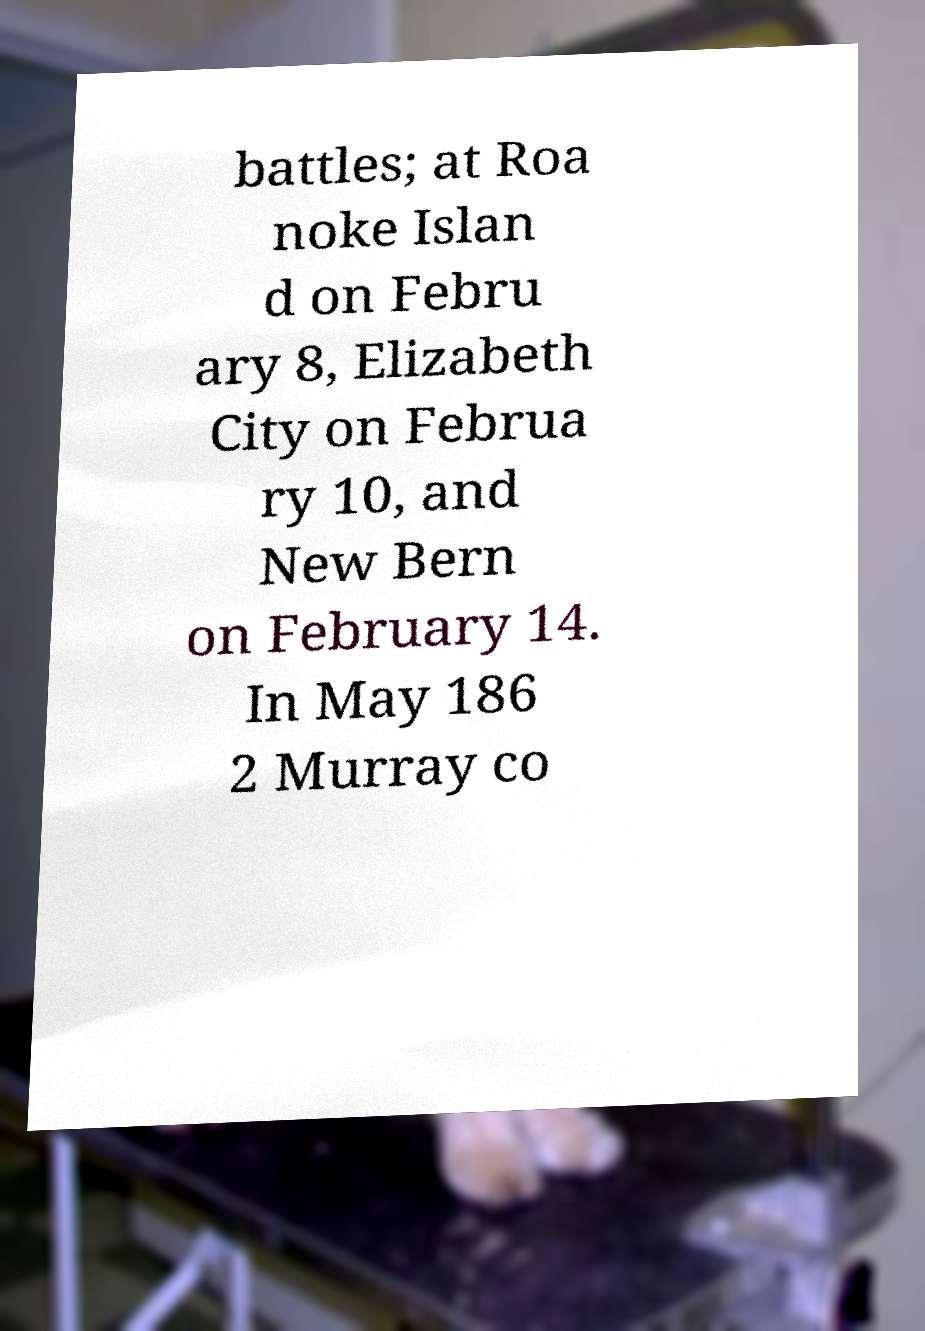For documentation purposes, I need the text within this image transcribed. Could you provide that? battles; at Roa noke Islan d on Febru ary 8, Elizabeth City on Februa ry 10, and New Bern on February 14. In May 186 2 Murray co 